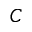<formula> <loc_0><loc_0><loc_500><loc_500>C</formula> 